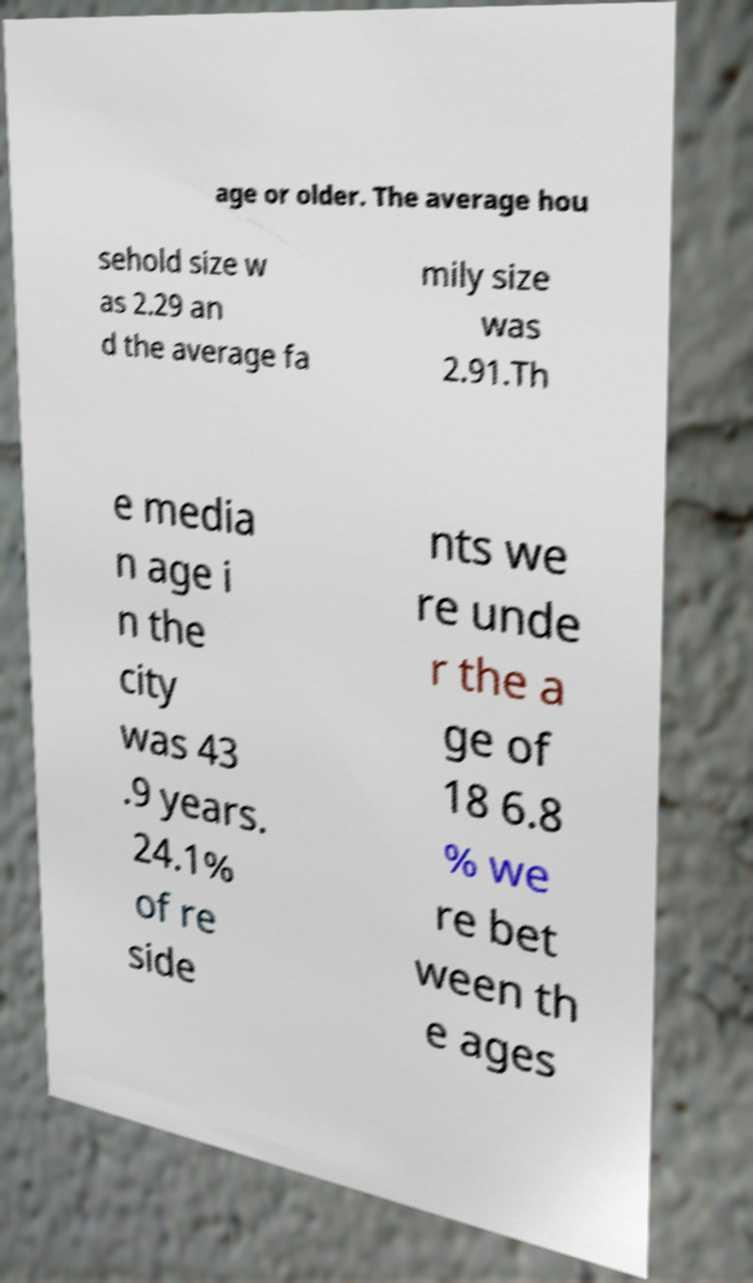There's text embedded in this image that I need extracted. Can you transcribe it verbatim? age or older. The average hou sehold size w as 2.29 an d the average fa mily size was 2.91.Th e media n age i n the city was 43 .9 years. 24.1% of re side nts we re unde r the a ge of 18 6.8 % we re bet ween th e ages 